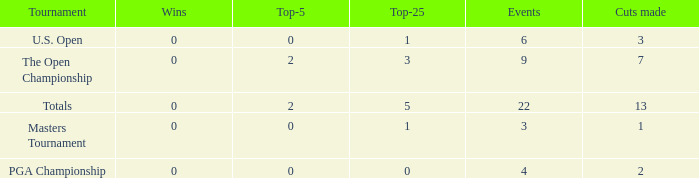How many total cuts were made in events with more than 0 wins and exactly 0 top-5s? 0.0. 